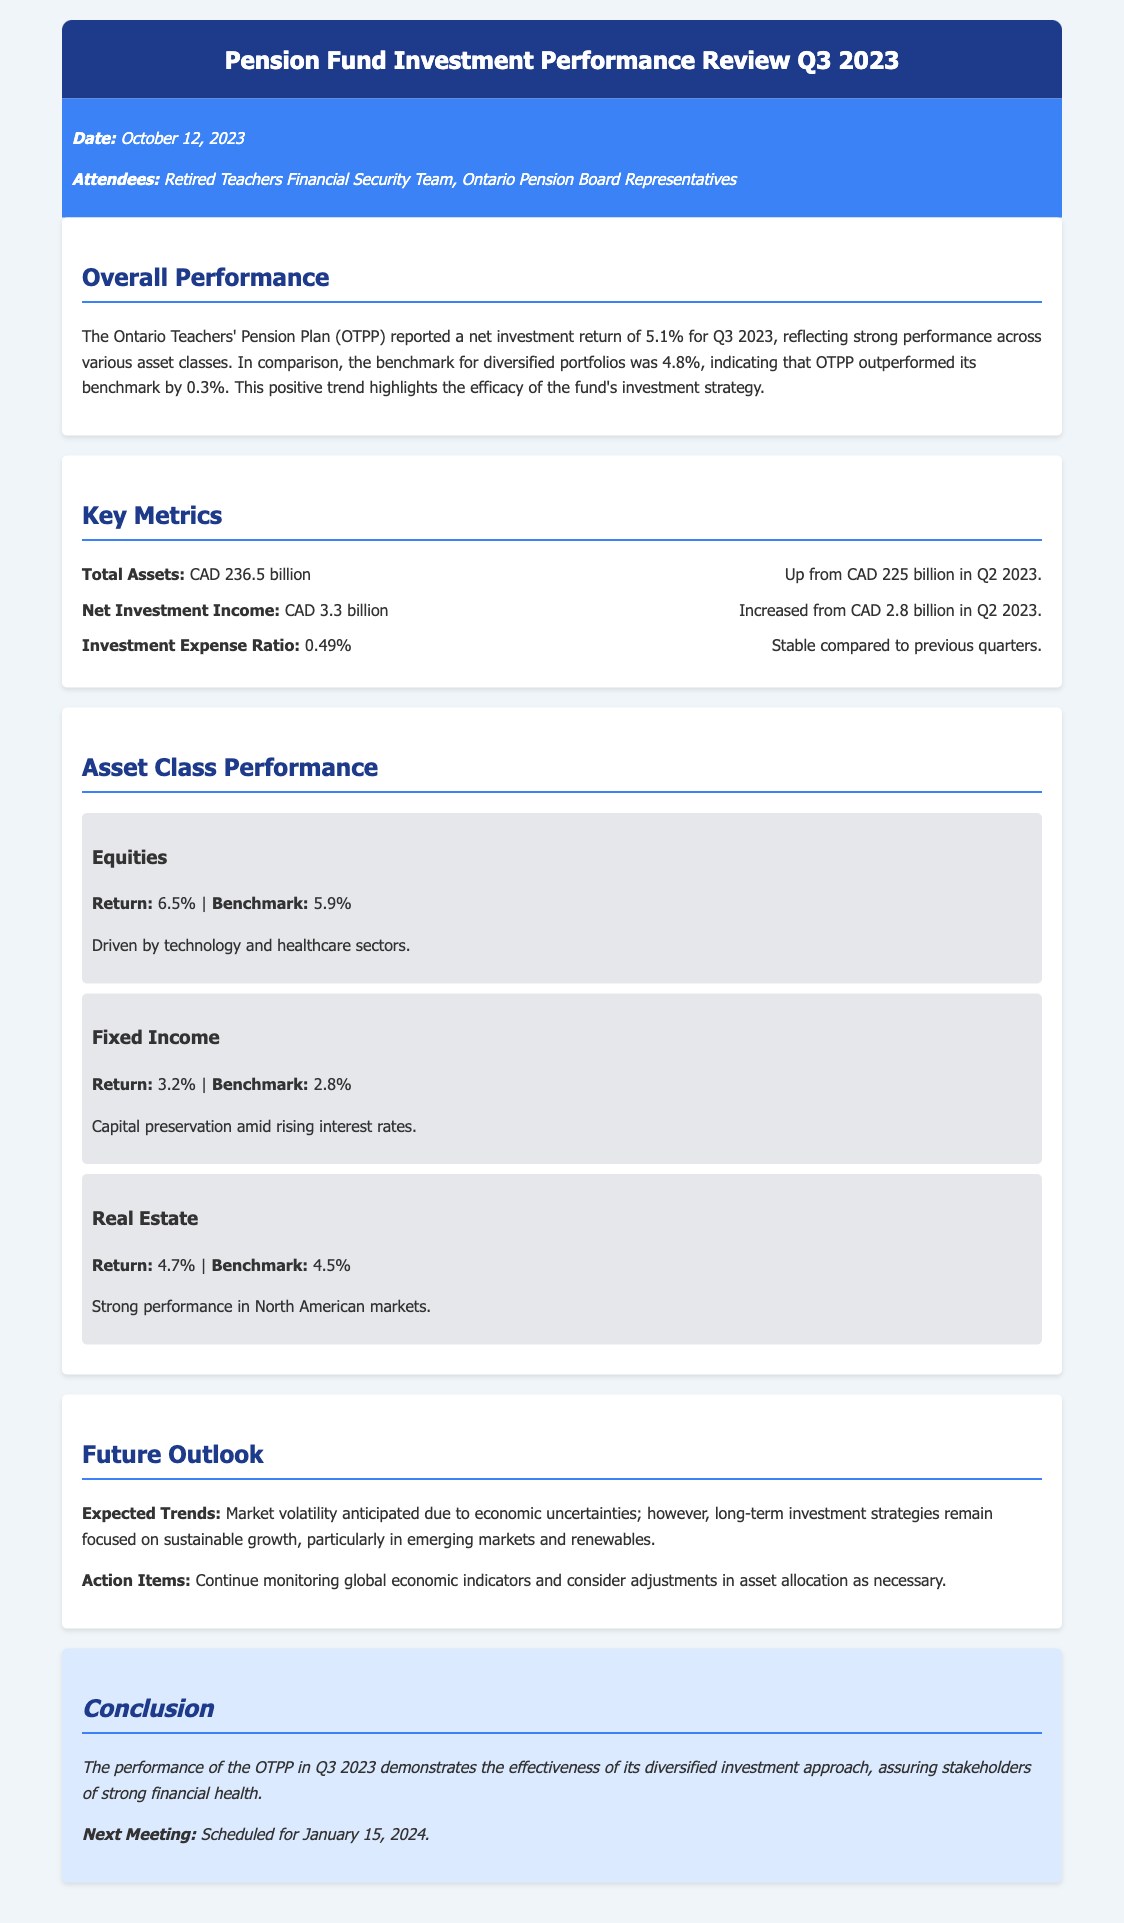What is the net investment return for Q3 2023? The document states that the net investment return for Q3 2023 is 5.1%.
Answer: 5.1% What was the benchmark return for diversified portfolios? The benchmark for diversified portfolios for the same period is identified as 4.8%.
Answer: 4.8% How much did the total assets increase from Q2 2023 to Q3 2023? The total assets increased from CAD 225 billion in Q2 2023 to CAD 236.5 billion in Q3 2023, which is an increase of CAD 11.5 billion.
Answer: CAD 11.5 billion What sector drove the equities return? The document mentions that the equities return was driven by the technology and healthcare sectors.
Answer: technology and healthcare What is the investment expense ratio? The investment expense ratio listed in the document is 0.49%.
Answer: 0.49% What is the expected market trend outlined in the future outlook? The document describes the expected trend as market volatility due to economic uncertainties.
Answer: market volatility What is the scheduled date for the next meeting? The next meeting is scheduled for January 15, 2024.
Answer: January 15, 2024 Which asset class had the highest return in Q3 2023? The asset class with the highest return is identified as Equities with a return of 6.5%.
Answer: Equities What primary investment focus was mentioned for the long-term strategy? The document emphasizes a focus on sustainable growth, particularly in emerging markets and renewables.
Answer: sustainable growth in emerging markets and renewables 